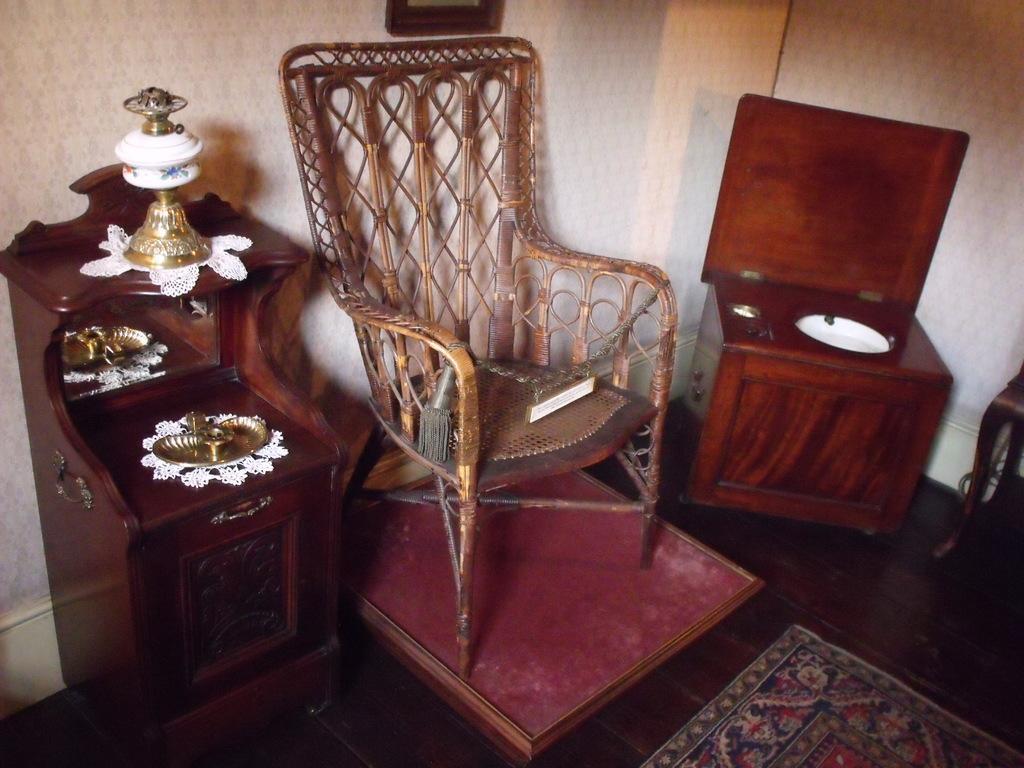Can you describe this image briefly? In the center of the image we can see chair. On the right side of the image we can see table. On the left side of the image we can see some objects placed on the table. In the background there is wall. At the bottom we can see mats. 